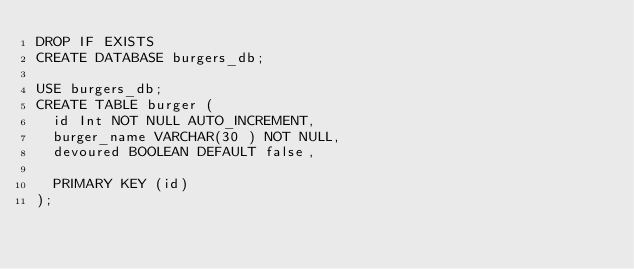Convert code to text. <code><loc_0><loc_0><loc_500><loc_500><_SQL_>DROP IF EXISTS
CREATE DATABASE burgers_db;

USE burgers_db;
CREATE TABLE burger (
  id Int NOT NULL AUTO_INCREMENT,
  burger_name VARCHAR(30 ) NOT NULL,
  devoured BOOLEAN DEFAULT false,

  PRIMARY KEY (id) 
);</code> 